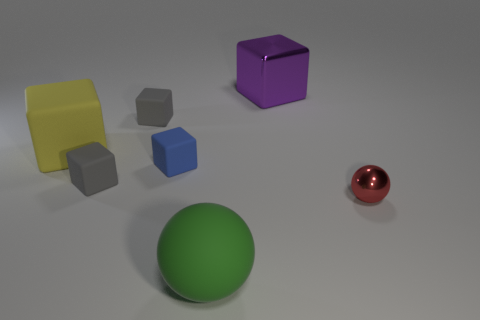There is a ball that is on the right side of the large object that is in front of the ball to the right of the green thing; what is its size?
Provide a short and direct response. Small. There is a red object that is the same size as the blue rubber cube; what is its shape?
Your answer should be compact. Sphere. What number of objects are blue matte things in front of the purple block or yellow cubes?
Give a very brief answer. 2. Are there any large cubes that are on the right side of the ball on the left side of the metal thing that is left of the small shiny thing?
Keep it short and to the point. Yes. How many tiny red matte things are there?
Make the answer very short. 0. What number of things are either balls that are to the right of the big purple metallic thing or spheres on the right side of the purple metal cube?
Your response must be concise. 1. Do the gray rubber block that is in front of the blue thing and the red thing have the same size?
Ensure brevity in your answer.  Yes. The green object that is the same shape as the red metal thing is what size?
Provide a short and direct response. Large. There is a yellow object that is the same size as the green sphere; what is its material?
Your response must be concise. Rubber. There is a purple thing that is the same shape as the blue rubber object; what material is it?
Offer a very short reply. Metal. 